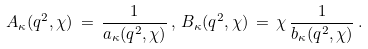Convert formula to latex. <formula><loc_0><loc_0><loc_500><loc_500>A _ { \kappa } ( q ^ { 2 } , \chi ) \, = \, \frac { 1 } { a _ { \kappa } ( q ^ { 2 } , \chi ) } \, , \, B _ { \kappa } ( q ^ { 2 } , \chi ) \, = \, \chi \, \frac { 1 } { b _ { \kappa } ( q ^ { 2 } , \chi ) } \, .</formula> 